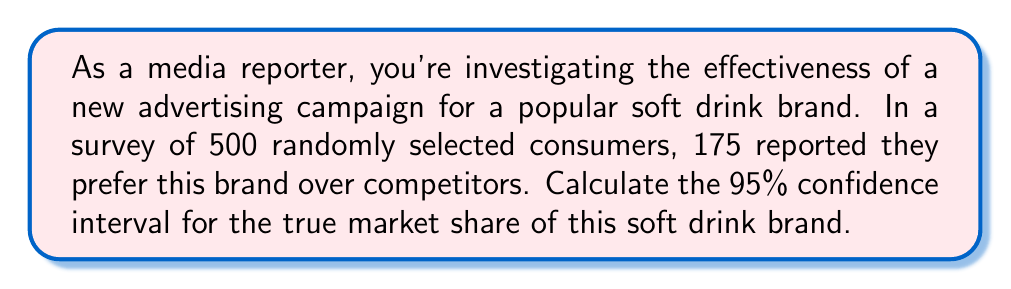Solve this math problem. Let's approach this step-by-step:

1) First, we need to calculate the point estimate (p̂) for the proportion:
   $\hat{p} = \frac{\text{number of successes}}{\text{sample size}} = \frac{175}{500} = 0.35$ or 35%

2) For a 95% confidence interval, we use a z-score of 1.96 (from the standard normal distribution table).

3) The formula for the confidence interval is:

   $$\hat{p} \pm z \sqrt{\frac{\hat{p}(1-\hat{p})}{n}}$$

   Where:
   - $\hat{p}$ is the sample proportion (0.35)
   - $z$ is the z-score (1.96 for 95% confidence)
   - $n$ is the sample size (500)

4) Let's calculate the margin of error:

   $$1.96 \sqrt{\frac{0.35(1-0.35)}{500}} = 1.96 \sqrt{\frac{0.2275}{500}} = 1.96 \sqrt{0.000455} = 1.96 * 0.0213 = 0.0418$$

5) Now, we can calculate the confidence interval:

   Lower bound: $0.35 - 0.0418 = 0.3082$ or 30.82%
   Upper bound: $0.35 + 0.0418 = 0.3918$ or 39.18%

Therefore, we can be 95% confident that the true market share for this soft drink brand is between 30.82% and 39.18%.
Answer: (30.82%, 39.18%) 